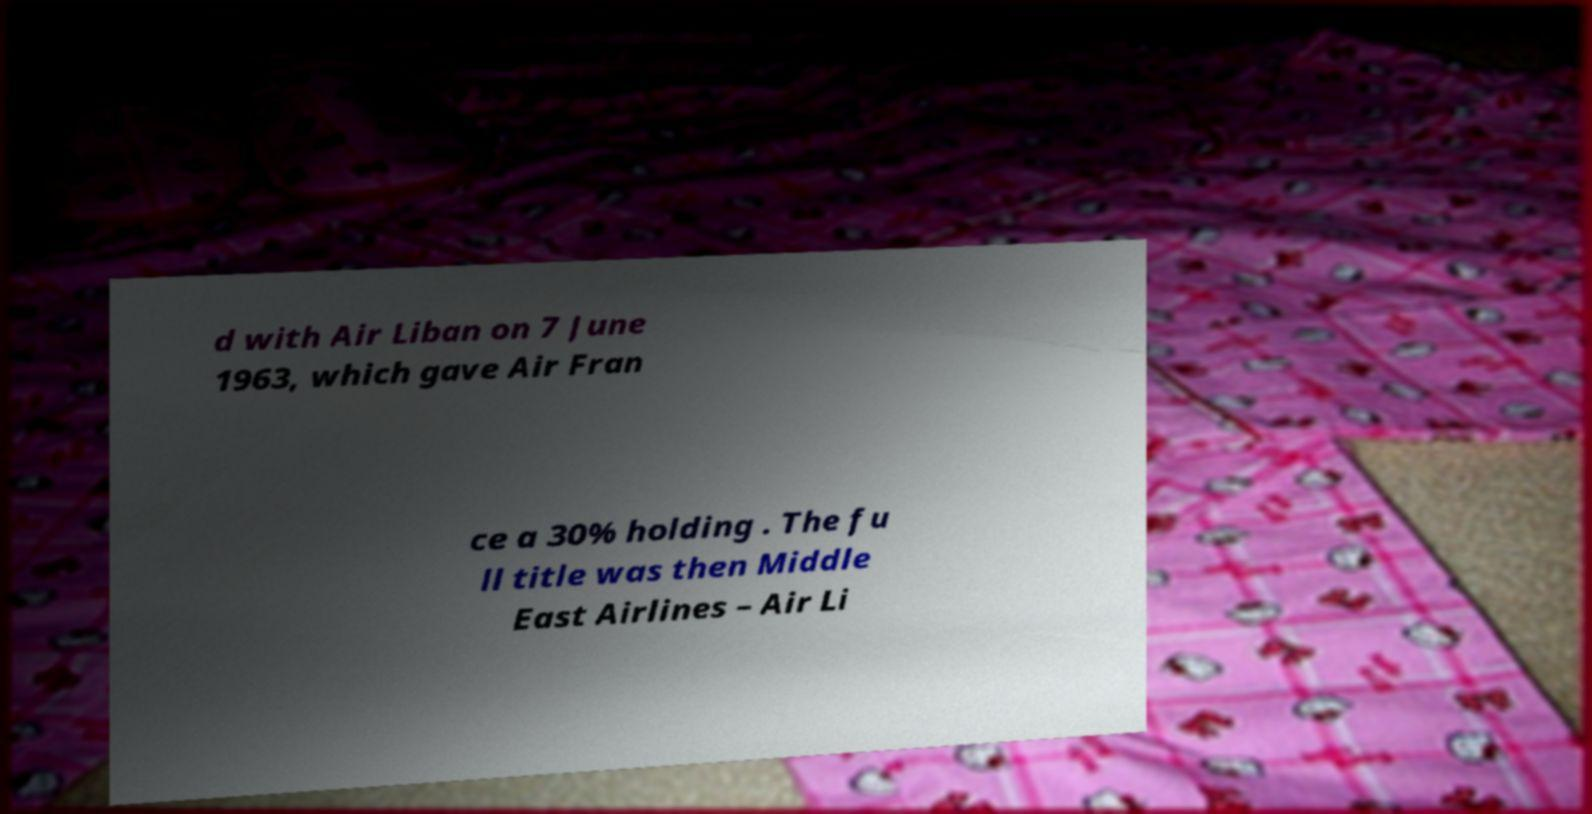Could you extract and type out the text from this image? d with Air Liban on 7 June 1963, which gave Air Fran ce a 30% holding . The fu ll title was then Middle East Airlines – Air Li 